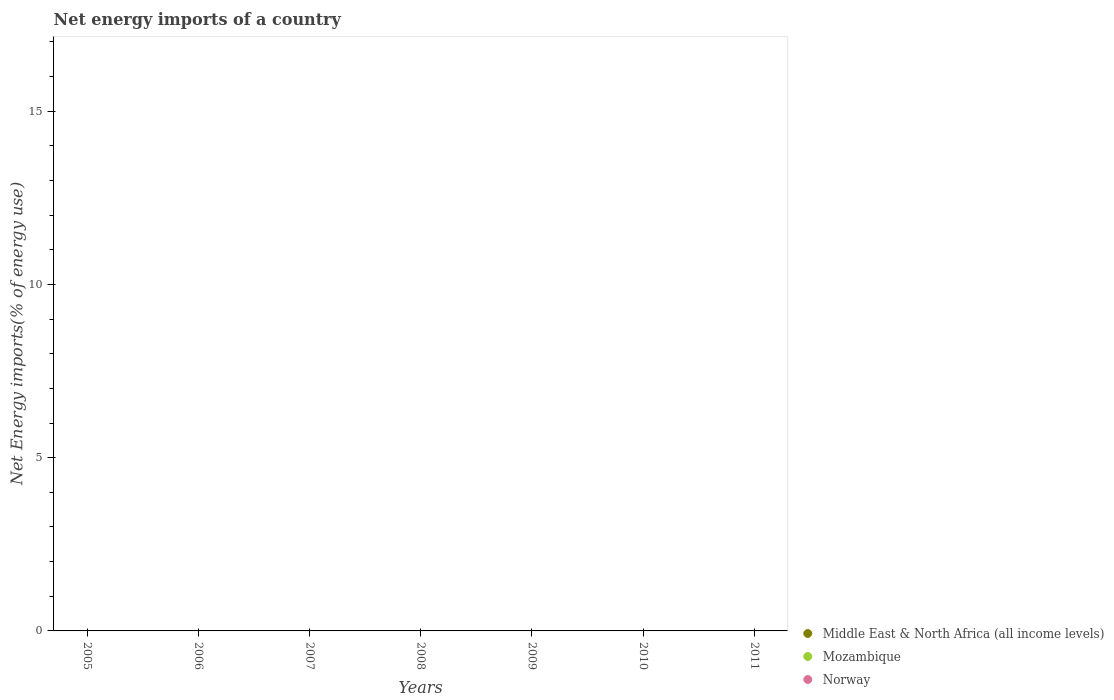What is the net energy imports in Mozambique in 2005?
Your answer should be very brief. 0. Across all years, what is the minimum net energy imports in Middle East & North Africa (all income levels)?
Offer a terse response. 0. What is the total net energy imports in Mozambique in the graph?
Your answer should be very brief. 0. What is the average net energy imports in Mozambique per year?
Keep it short and to the point. 0. In how many years, is the net energy imports in Middle East & North Africa (all income levels) greater than 16 %?
Ensure brevity in your answer.  0. In how many years, is the net energy imports in Middle East & North Africa (all income levels) greater than the average net energy imports in Middle East & North Africa (all income levels) taken over all years?
Offer a terse response. 0. Is the net energy imports in Norway strictly greater than the net energy imports in Mozambique over the years?
Offer a very short reply. No. Is the net energy imports in Norway strictly less than the net energy imports in Mozambique over the years?
Provide a succinct answer. Yes. How many dotlines are there?
Your response must be concise. 0. How many years are there in the graph?
Make the answer very short. 7. Does the graph contain any zero values?
Your response must be concise. Yes. Where does the legend appear in the graph?
Provide a short and direct response. Bottom right. How many legend labels are there?
Keep it short and to the point. 3. How are the legend labels stacked?
Your answer should be compact. Vertical. What is the title of the graph?
Make the answer very short. Net energy imports of a country. What is the label or title of the Y-axis?
Provide a succinct answer. Net Energy imports(% of energy use). What is the Net Energy imports(% of energy use) of Middle East & North Africa (all income levels) in 2005?
Offer a very short reply. 0. What is the Net Energy imports(% of energy use) in Mozambique in 2005?
Provide a short and direct response. 0. What is the Net Energy imports(% of energy use) of Norway in 2005?
Ensure brevity in your answer.  0. What is the Net Energy imports(% of energy use) of Mozambique in 2006?
Offer a very short reply. 0. What is the Net Energy imports(% of energy use) in Norway in 2006?
Your response must be concise. 0. What is the Net Energy imports(% of energy use) in Middle East & North Africa (all income levels) in 2007?
Make the answer very short. 0. What is the Net Energy imports(% of energy use) in Mozambique in 2008?
Offer a very short reply. 0. What is the Net Energy imports(% of energy use) of Norway in 2008?
Make the answer very short. 0. What is the Net Energy imports(% of energy use) of Norway in 2009?
Your answer should be very brief. 0. What is the Net Energy imports(% of energy use) in Mozambique in 2010?
Ensure brevity in your answer.  0. What is the Net Energy imports(% of energy use) of Norway in 2010?
Offer a terse response. 0. What is the Net Energy imports(% of energy use) of Middle East & North Africa (all income levels) in 2011?
Make the answer very short. 0. What is the Net Energy imports(% of energy use) in Mozambique in 2011?
Make the answer very short. 0. What is the total Net Energy imports(% of energy use) in Middle East & North Africa (all income levels) in the graph?
Your response must be concise. 0. What is the total Net Energy imports(% of energy use) in Mozambique in the graph?
Give a very brief answer. 0. What is the total Net Energy imports(% of energy use) of Norway in the graph?
Give a very brief answer. 0. What is the average Net Energy imports(% of energy use) in Middle East & North Africa (all income levels) per year?
Offer a terse response. 0. What is the average Net Energy imports(% of energy use) of Mozambique per year?
Ensure brevity in your answer.  0. What is the average Net Energy imports(% of energy use) in Norway per year?
Keep it short and to the point. 0. 